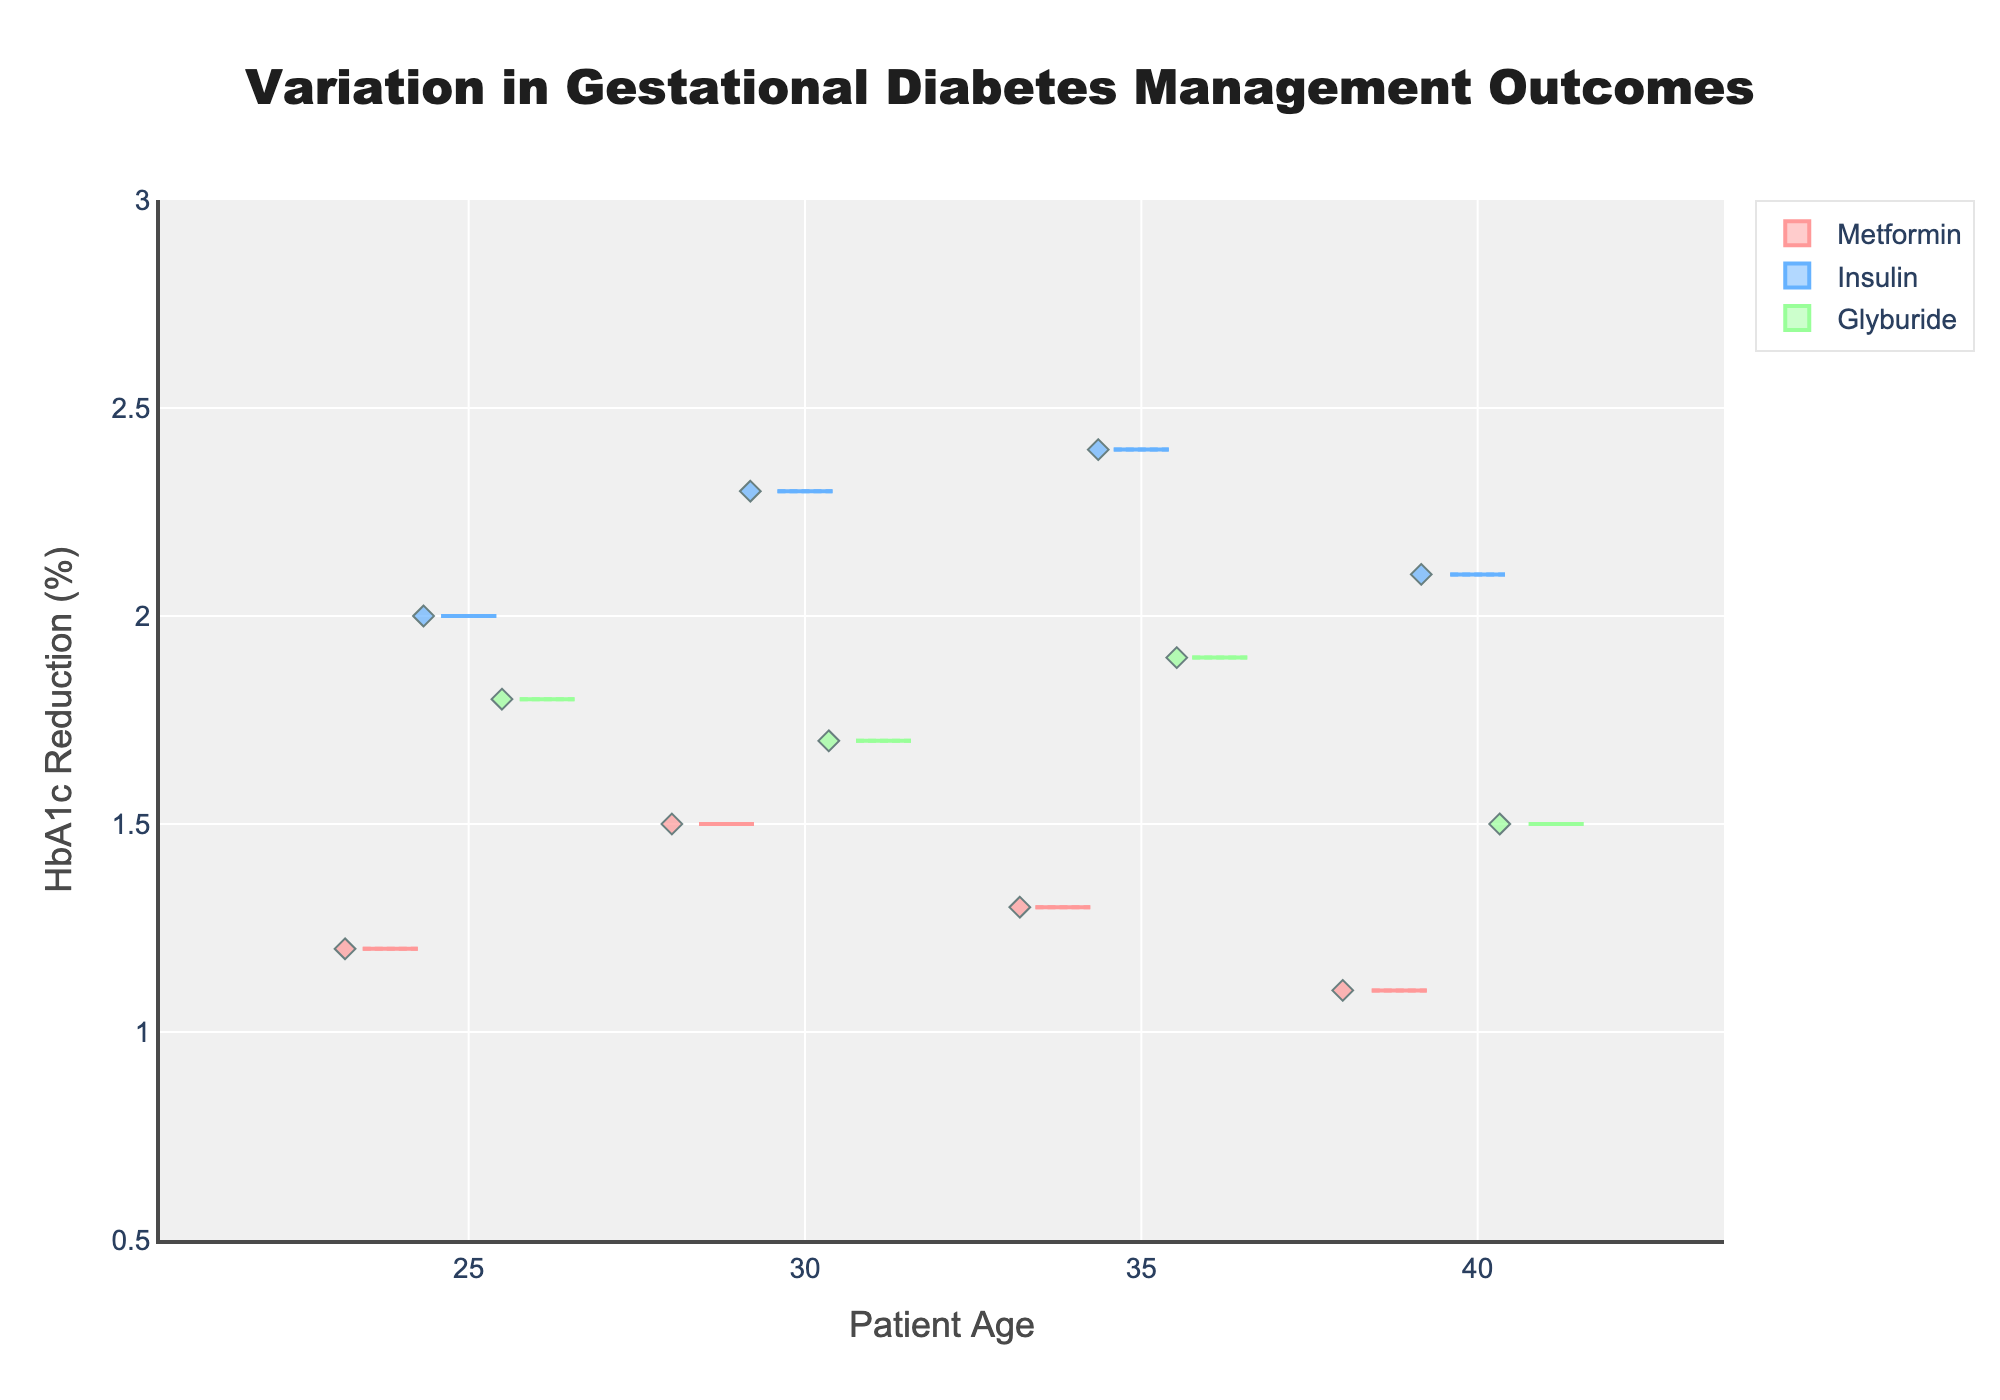What is the title of the figure? The title is located at the top of the figure, and it provides a summary of what the plot represents.
Answer: Variation in Gestational Diabetes Management Outcomes What does the y-axis represent? The y-axis label explains the outcome being measured in the plot. It represents the percentage reduction in HbA1c levels.
Answer: HbA1c Reduction (%) Which medication type shows the highest median HbA1c reduction for the 35-year-old age group? To find the answer, look at the median line inside the boxes for the 35-year-old age group and compare them across different medication types.
Answer: Insulin What are the colors used for each medication type? The plot uses color coding to differentiate between medication types. Identify each color and its corresponding medication type from the legend.
Answer: Metformin: pink, Insulin: blue, Glyburide: green For the 40-year-old age group, which medication has the smallest interquartile range (IQR)? The interquartile range is the distance between the first quartile (25th percentile) and the third quartile (75th percentile). Compare the box heights for each medication type in the 40-year-old age group.
Answer: Metformin How does the mean HbA1c reduction for Metformin compare across different age groups? Each box shows the mean as a symbol (often a circle or diamond). Compare the means across the boxes for Metformin at each age group.
Answer: The mean HbA1c reduction for Metformin decreases slightly as age increases Which age group shows the highest variability in HbA1c reduction for Insulin? Variability can be assessed by the height of the box and the length of the whiskers. Look at the different boxes for Insulin and identify the one with the largest spread.
Answer: 35-year-old Is there any medication type that consistently has a lower HbA1c reduction compared to others across all age groups? Compare the median HbA1c reduction values (the middle line in each box) for each medication type across all age groups. Determine if one medication consistently has a lower median.
Answer: Metformin What is the range of HbA1c reductions seen in the 30-year-old group for Glyburide? The range is determined by the highest and lowest data points excluding outliers, which can be seen by the ends of the whiskers. Look at the 30-year-old group for Glyburide and note the highest and lowest points.
Answer: 1.7% to 1.7% 